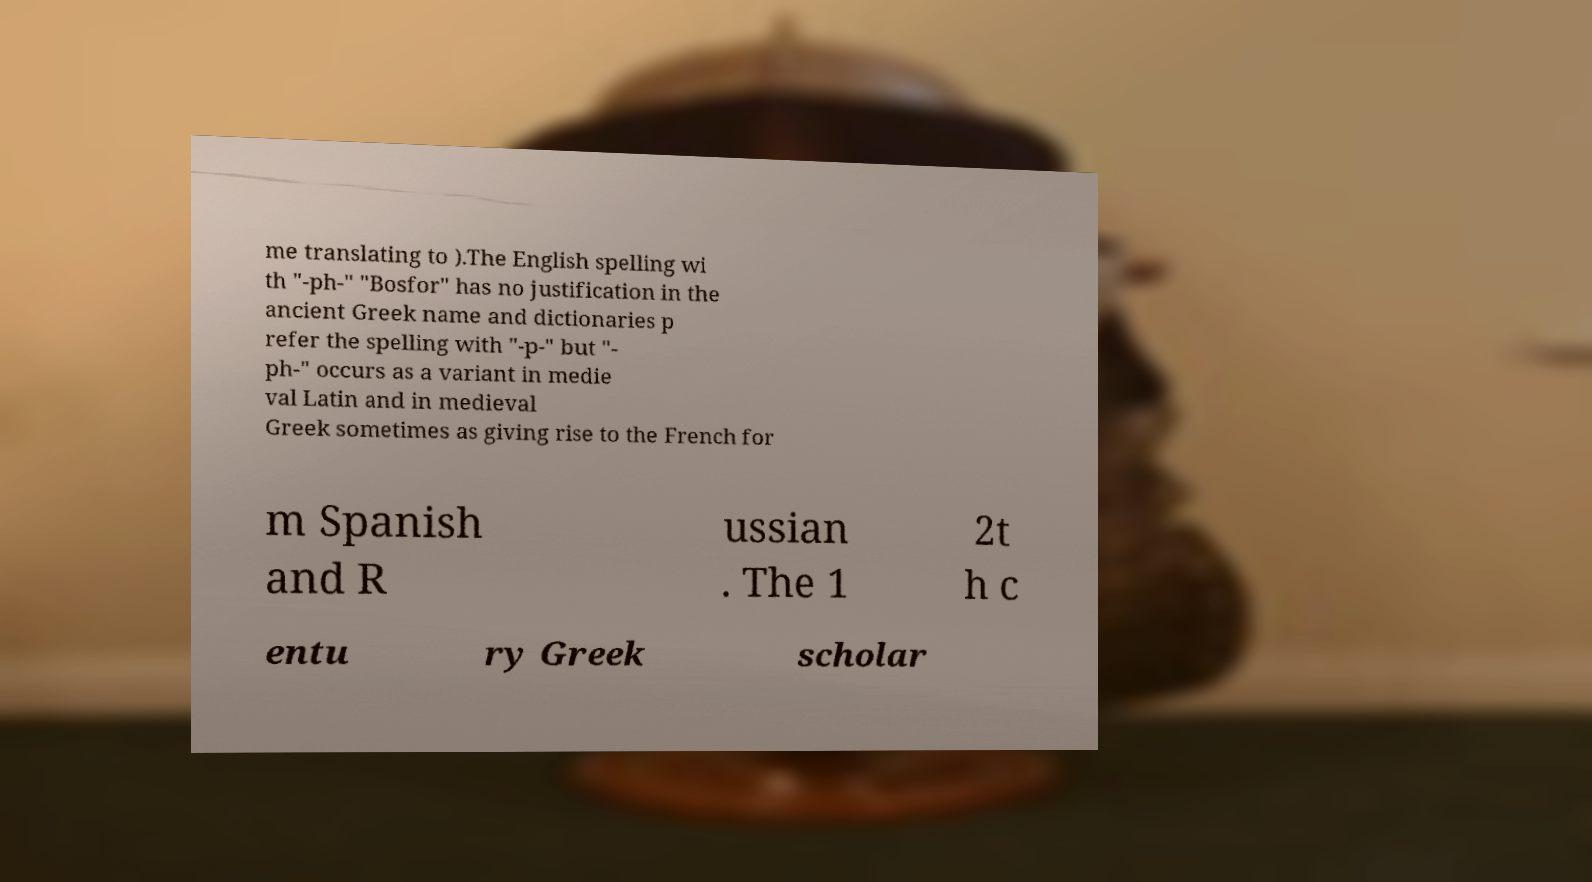Please identify and transcribe the text found in this image. me translating to ).The English spelling wi th "-ph-" "Bosfor" has no justification in the ancient Greek name and dictionaries p refer the spelling with "-p-" but "- ph-" occurs as a variant in medie val Latin and in medieval Greek sometimes as giving rise to the French for m Spanish and R ussian . The 1 2t h c entu ry Greek scholar 